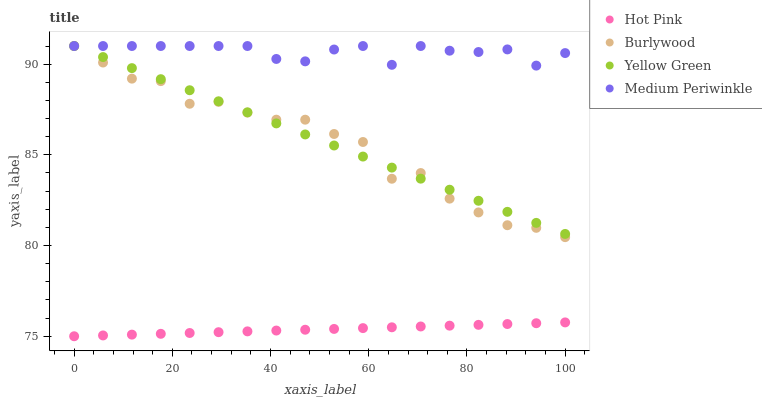Does Hot Pink have the minimum area under the curve?
Answer yes or no. Yes. Does Medium Periwinkle have the maximum area under the curve?
Answer yes or no. Yes. Does Medium Periwinkle have the minimum area under the curve?
Answer yes or no. No. Does Hot Pink have the maximum area under the curve?
Answer yes or no. No. Is Yellow Green the smoothest?
Answer yes or no. Yes. Is Burlywood the roughest?
Answer yes or no. Yes. Is Hot Pink the smoothest?
Answer yes or no. No. Is Hot Pink the roughest?
Answer yes or no. No. Does Hot Pink have the lowest value?
Answer yes or no. Yes. Does Medium Periwinkle have the lowest value?
Answer yes or no. No. Does Yellow Green have the highest value?
Answer yes or no. Yes. Does Hot Pink have the highest value?
Answer yes or no. No. Is Hot Pink less than Yellow Green?
Answer yes or no. Yes. Is Burlywood greater than Hot Pink?
Answer yes or no. Yes. Does Medium Periwinkle intersect Yellow Green?
Answer yes or no. Yes. Is Medium Periwinkle less than Yellow Green?
Answer yes or no. No. Is Medium Periwinkle greater than Yellow Green?
Answer yes or no. No. Does Hot Pink intersect Yellow Green?
Answer yes or no. No. 